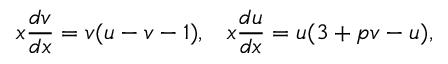<formula> <loc_0><loc_0><loc_500><loc_500>x \frac { d v } { d x } = v ( u - v - 1 ) , \, x \frac { d u } { d x } = u ( 3 + p v - u ) ,</formula> 